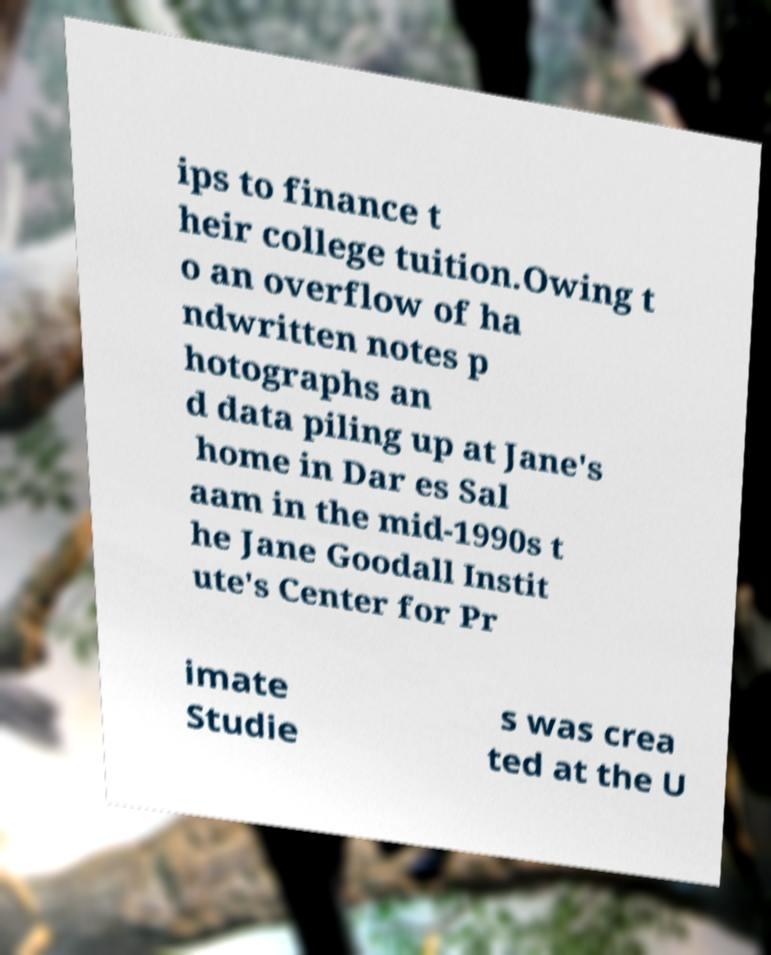Please identify and transcribe the text found in this image. ips to finance t heir college tuition.Owing t o an overflow of ha ndwritten notes p hotographs an d data piling up at Jane's home in Dar es Sal aam in the mid-1990s t he Jane Goodall Instit ute's Center for Pr imate Studie s was crea ted at the U 